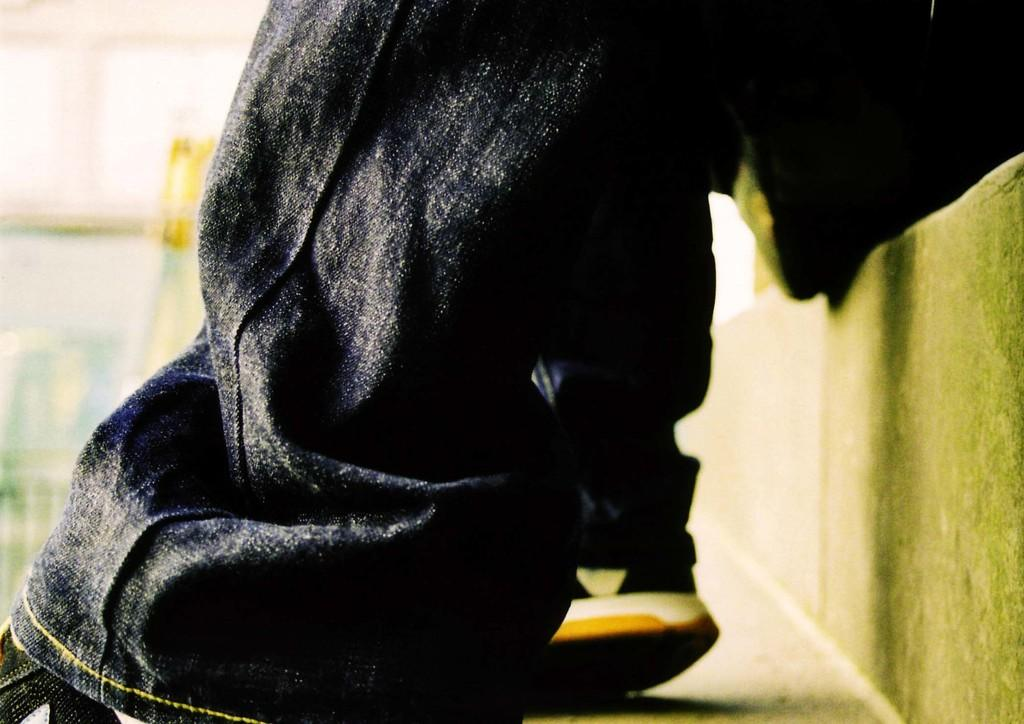What part of a person's body is visible in the image? The image shows a person's legs. What type of clothing is the person wearing? The person is wearing a dress. What type of footwear is the person wearing? The person is wearing footwear. Can you describe the background of the image? The background of the image is blurred. What type of stem can be seen growing from the person's foot in the image? There is no stem growing from the person's foot in the image. How does the person's smile affect the overall composition of the image? The person's smile is not visible in the image, as only their legs are shown. 